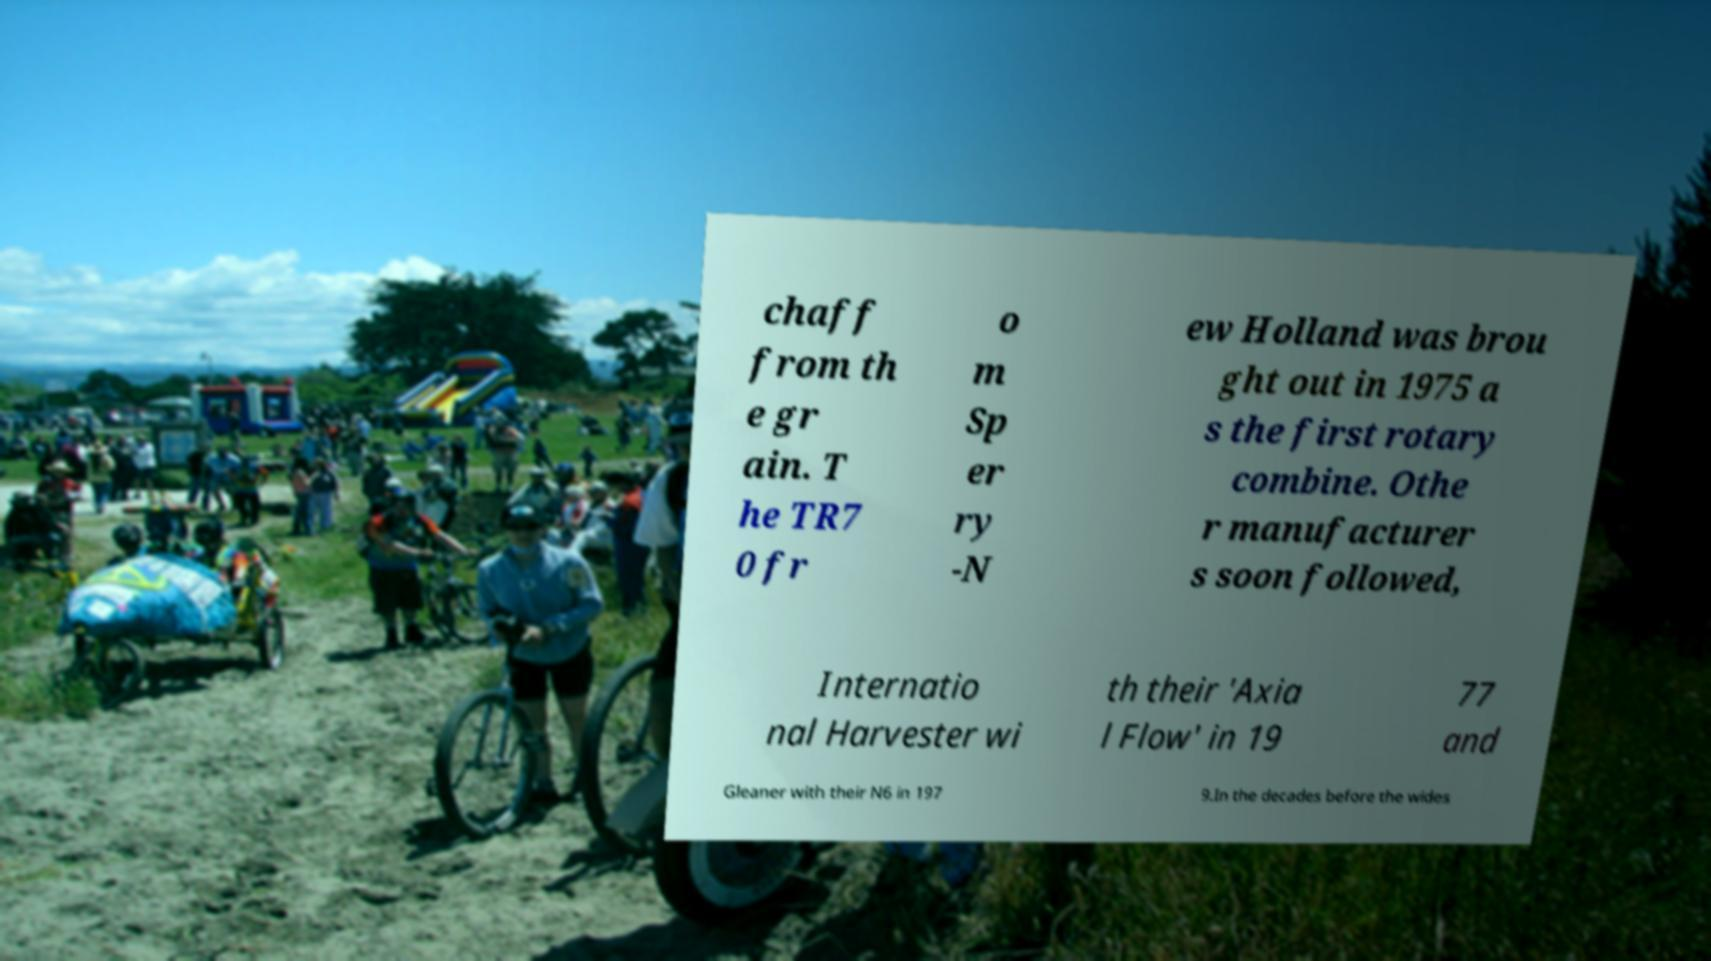Can you accurately transcribe the text from the provided image for me? chaff from th e gr ain. T he TR7 0 fr o m Sp er ry -N ew Holland was brou ght out in 1975 a s the first rotary combine. Othe r manufacturer s soon followed, Internatio nal Harvester wi th their 'Axia l Flow' in 19 77 and Gleaner with their N6 in 197 9.In the decades before the wides 